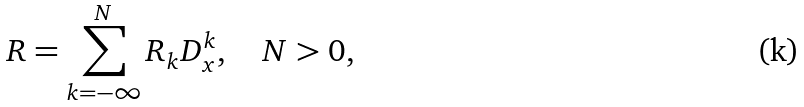Convert formula to latex. <formula><loc_0><loc_0><loc_500><loc_500>R = \sum _ { k = - \infty } ^ { N } R _ { k } D _ { x } ^ { k } , \quad N > 0 ,</formula> 